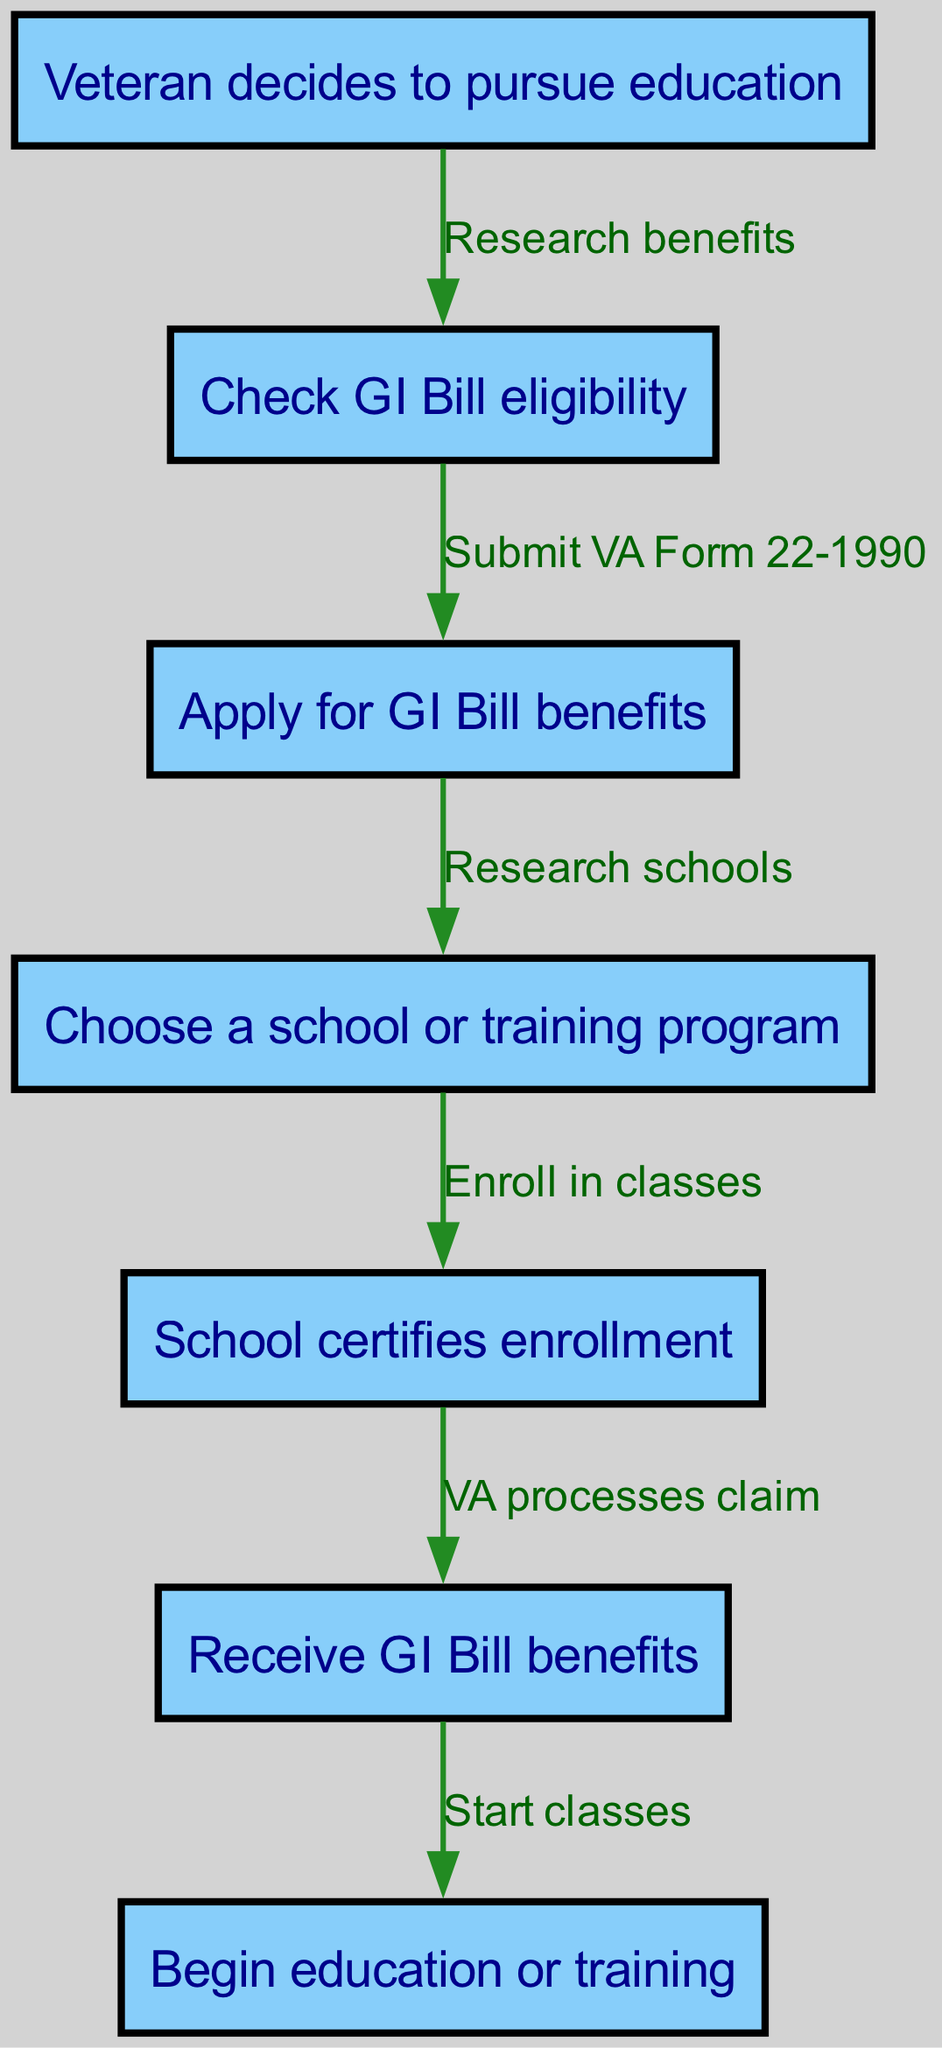What is the starting point of the GI Bill application process? The starting point of the process is the node labeled "Veteran decides to pursue education." This is defined as the first node in the diagram.
Answer: Veteran decides to pursue education How many nodes are present in the diagram? To find the number of nodes, we can count each of the unique nodes listed in the data. There are six nodes in total: "Veteran decides to pursue education," "Check GI Bill eligibility," "Apply for GI Bill benefits," "Choose a school or training program," "School certifies enrollment," and "Receive GI Bill benefits," leading us to a total of six nodes.
Answer: 6 What does the "Check GI Bill eligibility" node lead to? The "Check GI Bill eligibility" node leads to the "Apply for GI Bill benefits" node, as there is a directed edge connecting these two nodes in the flowchart.
Answer: Apply for GI Bill benefits Which node represents the action of receiving benefits? The node that represents the action of receiving benefits is labeled "Receive GI Bill benefits." This node directly indicates the receipt of benefits in the process.
Answer: Receive GI Bill benefits What procedure follows after "Enroll in classes"? After "Enroll in classes," the next procedure is that the "School certifies enrollment," indicating that enrollment must be certified by the school before receiving benefits.
Answer: School certifies enrollment What documents are submitted during the application stage? The document that is submitted during the application stage is the "VA Form 22-1990." This is specifically mentioned as part of the flow from eligibility to application.
Answer: VA Form 22-1990 How does a veteran begin their education after approval of benefits? A veteran begins their education once they have received their GI Bill benefits, which is indicated by the next step being "Start classes." This shows a clear progression from benefits to education.
Answer: Start classes Which action occurs just before the benefits are received? The action that occurs just before the benefits are received is the "VA processes claim," which is an essential step in the flow where the benefits are confirmed.
Answer: VA processes claim What is required before choosing a school or training program? Before choosing a school or training program, a veteran must apply for GI Bill benefits as per the flow sequence. This shows that application is a prerequisite for selecting an educational institution.
Answer: Apply for GI Bill benefits 